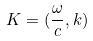<formula> <loc_0><loc_0><loc_500><loc_500>K = ( \frac { \omega } { c } , k )</formula> 